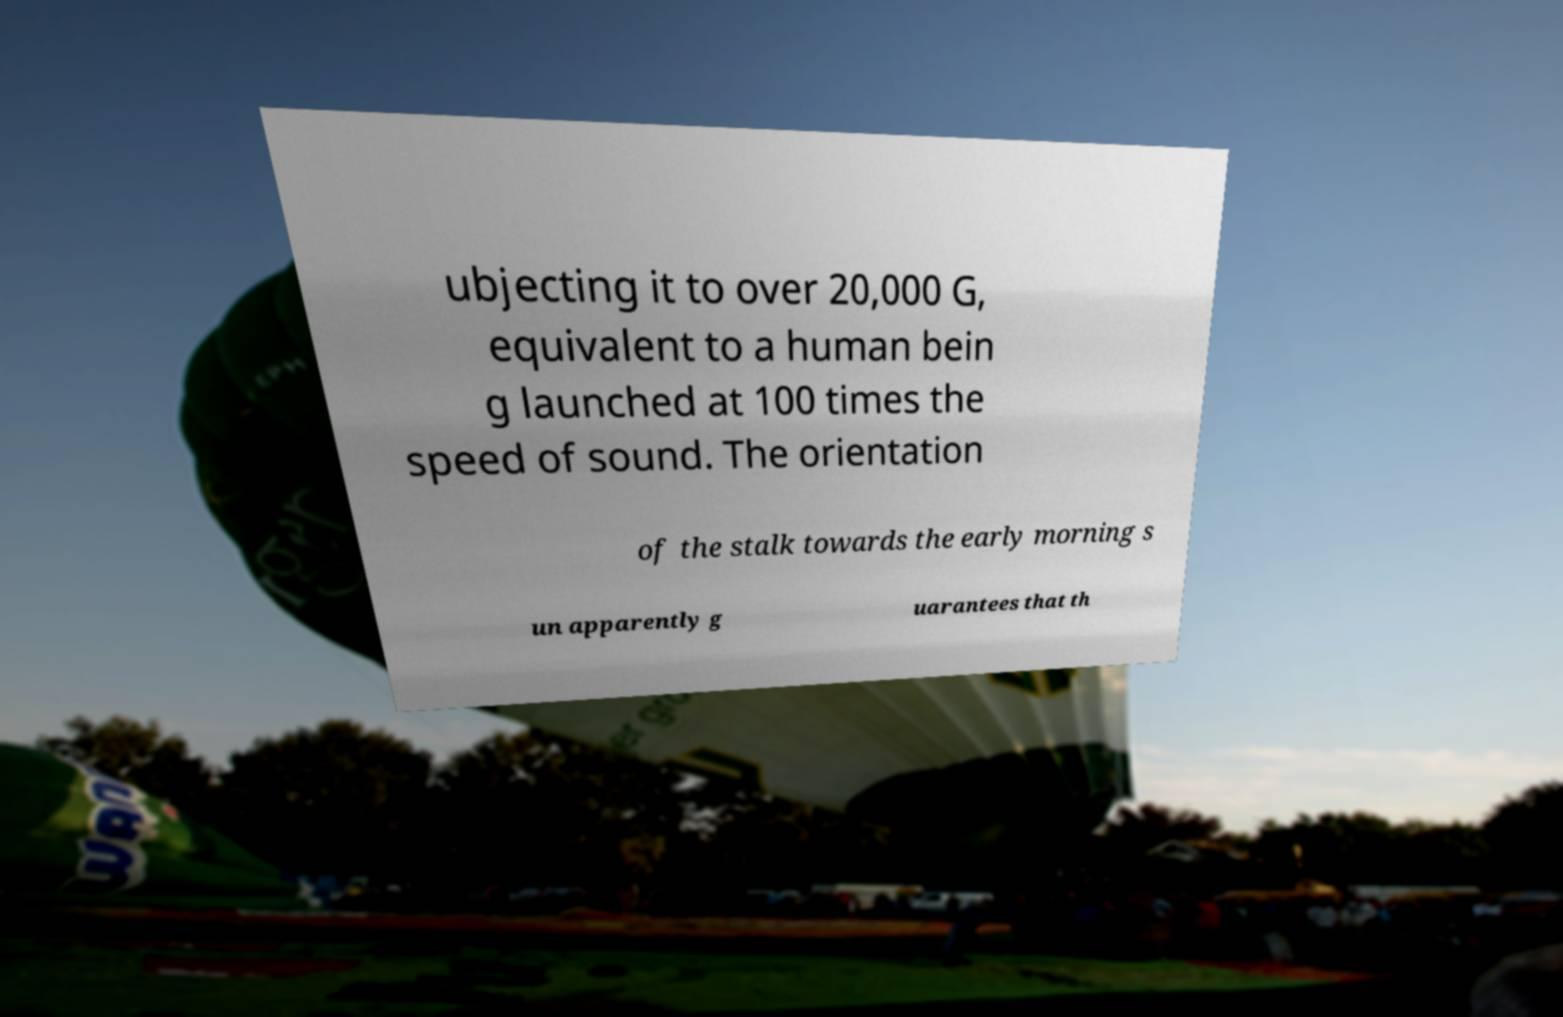Can you read and provide the text displayed in the image?This photo seems to have some interesting text. Can you extract and type it out for me? ubjecting it to over 20,000 G, equivalent to a human bein g launched at 100 times the speed of sound. The orientation of the stalk towards the early morning s un apparently g uarantees that th 